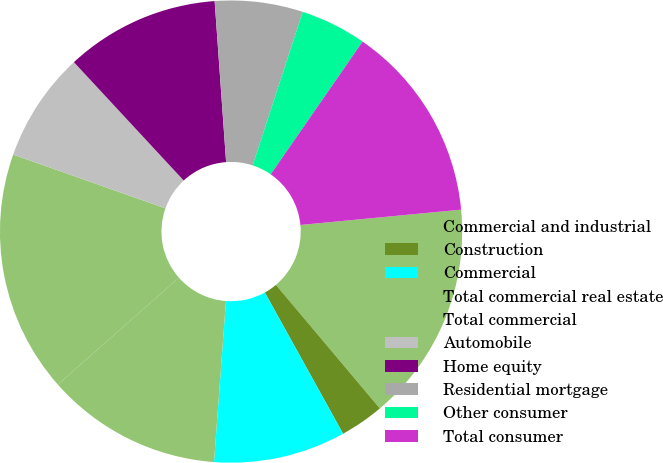<chart> <loc_0><loc_0><loc_500><loc_500><pie_chart><fcel>Commercial and industrial<fcel>Construction<fcel>Commercial<fcel>Total commercial real estate<fcel>Total commercial<fcel>Automobile<fcel>Home equity<fcel>Residential mortgage<fcel>Other consumer<fcel>Total consumer<nl><fcel>15.38%<fcel>3.08%<fcel>9.23%<fcel>12.31%<fcel>16.92%<fcel>7.69%<fcel>10.77%<fcel>6.15%<fcel>4.62%<fcel>13.85%<nl></chart> 